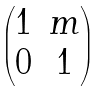<formula> <loc_0><loc_0><loc_500><loc_500>\begin{pmatrix} 1 & m \\ 0 & 1 \end{pmatrix}</formula> 